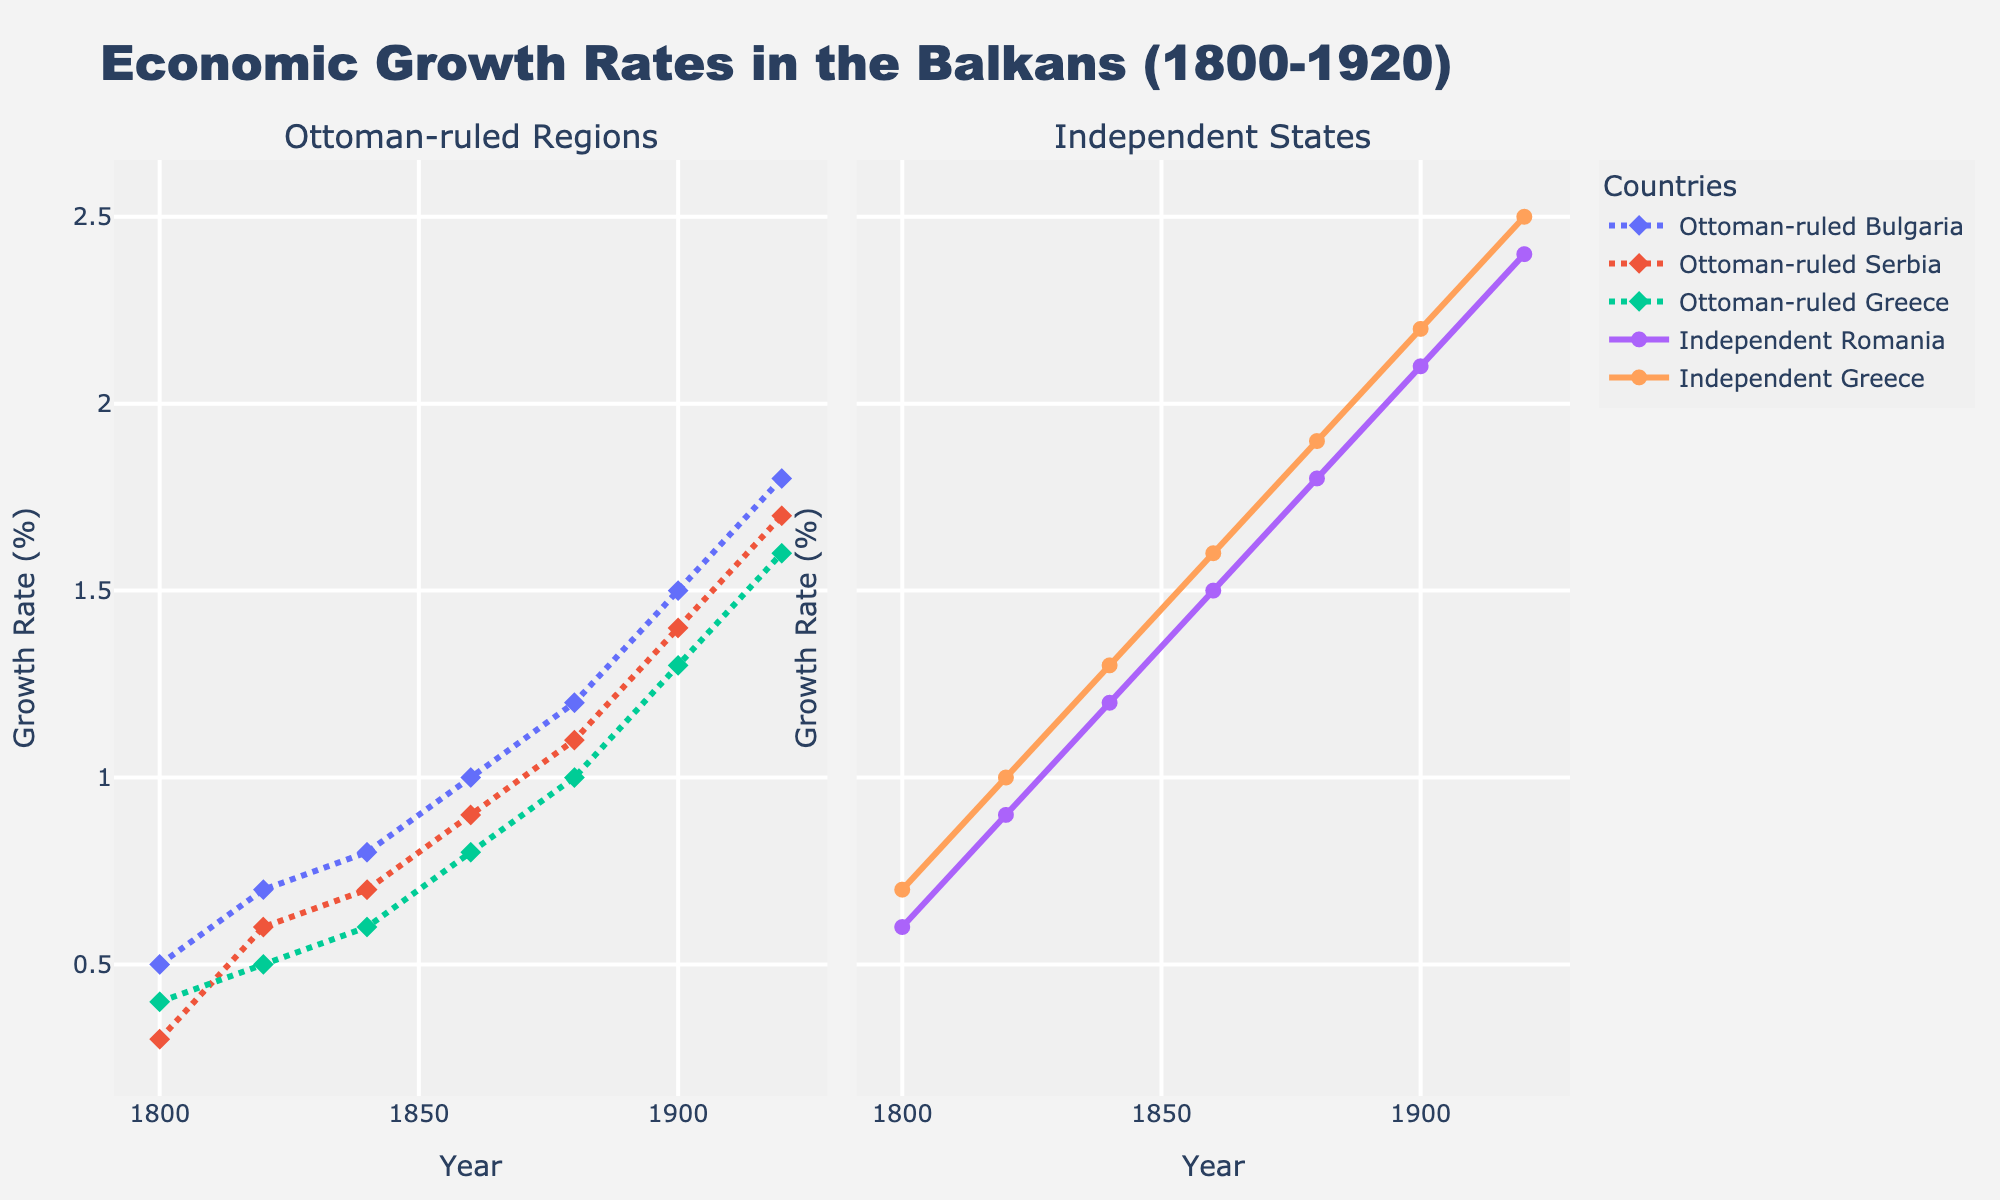What is the growth rate of the Ottoman-ruled regions in 1900? To find the growth rate, look at the data points for the year 1900 in the Ottoman-ruled Bulgaria, Serbia, and Greece. The rates are 1.5%, 1.4%, and 1.3%, respectively.
Answer: 1.5%, 1.4%, 1.3% How does the economic growth rate of Independent Greece in 1800 compare to that of Ottoman-ruled Greece in 1800? Look at the year 1800 for both Independent and Ottoman-ruled Greece. Independent Greece has a growth rate of 0.7% while Ottoman-ruled Greece has a rate of 0.4%. Comparing both values, Independent Greece has a higher growth rate.
Answer: Independent Greece has a higher rate Which region had the highest growth rate in 1920? Refer to the year 1920 data points for all regions: Ottoman-ruled Bulgaria (1.8%), Serbia (1.7%), Greece (1.6%), Independent Romania (2.4%), and Independent Greece (2.5%). Independent Greece had the highest growth rate.
Answer: Independent Greece What is the average growth rate of Ottoman-ruled regions in 1840? Calculate the average of the growth rates of Ottoman-ruled Bulgaria, Serbia, and Greece in 1840. (0.8 + 0.7 + 0.6) / 3 = 2.1 / 3 = 0.7%
Answer: 0.7% By how much did Ottoman-ruled Serbia’s growth rate increase from 1800 to 1920? Find the difference between the growth rates in 1800 and 1920 for Ottoman-ruled Serbia (1.7% - 0.3% = 1.4%).
Answer: 1.4% What is the difference in growth rates between Independent Romania and Ottoman-ruled Bulgaria in 1900? Subtract the growth rate of Ottoman-ruled Bulgaria from Independent Romania in 1900 (2.1% - 1.5% = 0.6%).
Answer: 0.6% Which had a steeper increase in growth rate between 1880 and 1900: Ottoman-ruled Serbia or Independent Romania? Calculate the increase for both regions: Ottoman-ruled Serbia (1.4% - 1.1% = 0.3%) and Independent Romania (2.1% - 1.8% = 0.3%). Both have the same increase.
Answer: Both had the same increase How did the growth rates of Independent Greece and Ottoman-ruled Greece evolve between 1800 and 1820? Note the growth rates in 1800 and 1820. Independent Greece went from 0.7% to 1.0%, and Ottoman-ruled Greece from 0.4% to 0.5%. Independent Greece shows a 0.3% increase, and Ottoman-ruled Greece shows only a 0.1% increase.
Answer: Independent Greece had a larger increase What is the combined growth rate of all Ottoman-ruled regions in 1920? Sum the growth rates for Ottoman-ruled Bulgaria, Serbia, and Greece in 1920: 1.8% + 1.7% + 1.6% = 5.1%.
Answer: 5.1% 